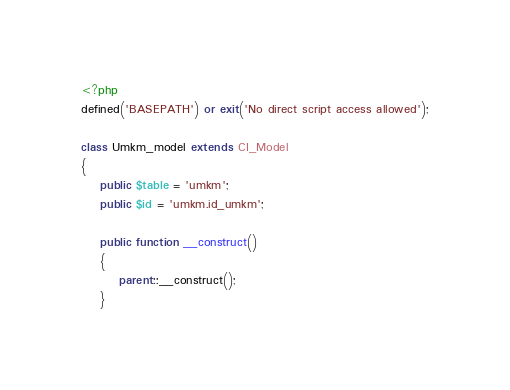<code> <loc_0><loc_0><loc_500><loc_500><_PHP_><?php
defined('BASEPATH') or exit('No direct script access allowed');

class Umkm_model extends CI_Model
{
    public $table = 'umkm';
    public $id = 'umkm.id_umkm';

    public function __construct()
    {
        parent::__construct();
    }
</code> 